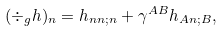Convert formula to latex. <formula><loc_0><loc_0><loc_500><loc_500>( \div _ { g } h ) _ { n } = h _ { n n ; n } + \gamma ^ { A B } h _ { A n ; B } ,</formula> 